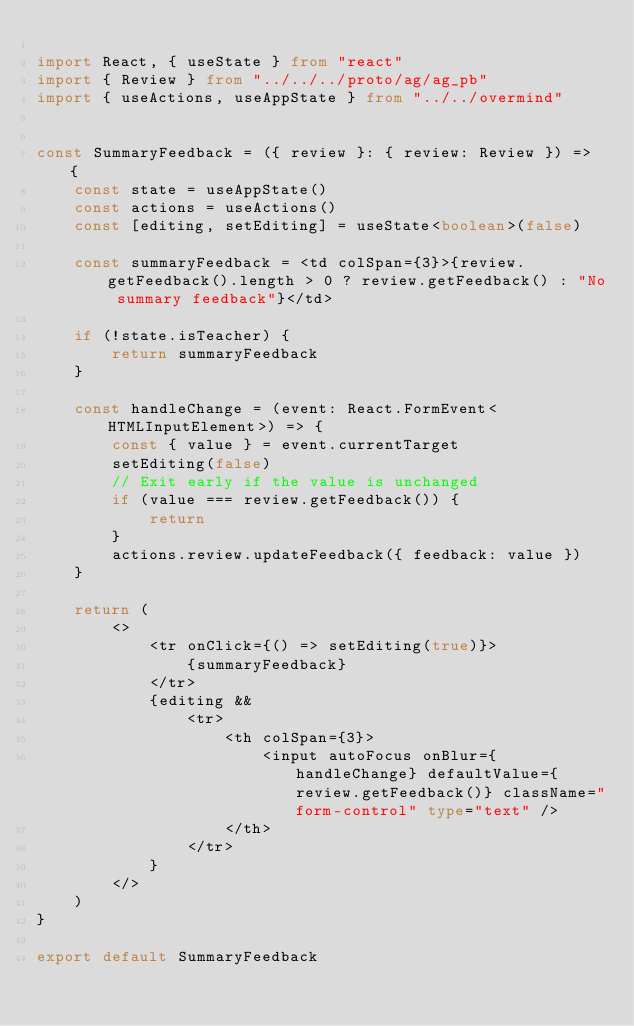Convert code to text. <code><loc_0><loc_0><loc_500><loc_500><_TypeScript_>
import React, { useState } from "react"
import { Review } from "../../../proto/ag/ag_pb"
import { useActions, useAppState } from "../../overmind"


const SummaryFeedback = ({ review }: { review: Review }) => {
    const state = useAppState()
    const actions = useActions()
    const [editing, setEditing] = useState<boolean>(false)

    const summaryFeedback = <td colSpan={3}>{review.getFeedback().length > 0 ? review.getFeedback() : "No summary feedback"}</td>

    if (!state.isTeacher) {
        return summaryFeedback
    }

    const handleChange = (event: React.FormEvent<HTMLInputElement>) => {
        const { value } = event.currentTarget
        setEditing(false)
        // Exit early if the value is unchanged
        if (value === review.getFeedback()) {
            return
        }
        actions.review.updateFeedback({ feedback: value })
    }

    return (
        <>
            <tr onClick={() => setEditing(true)}>
                {summaryFeedback}
            </tr>
            {editing &&
                <tr>
                    <th colSpan={3}>
                        <input autoFocus onBlur={handleChange} defaultValue={review.getFeedback()} className="form-control" type="text" />
                    </th>
                </tr>
            }
        </>
    )
}

export default SummaryFeedback
</code> 